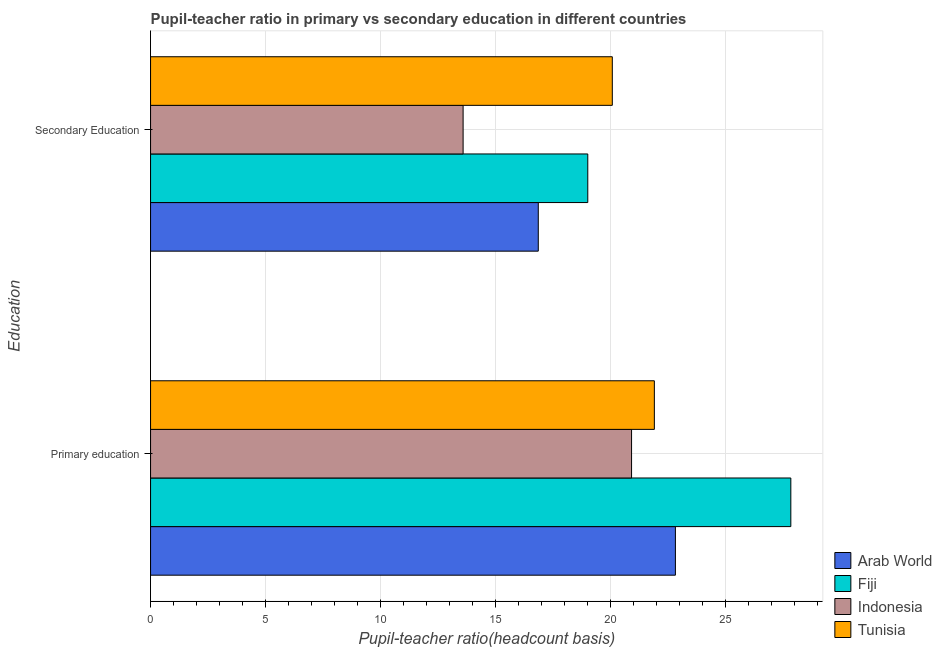How many different coloured bars are there?
Offer a terse response. 4. How many groups of bars are there?
Offer a terse response. 2. What is the pupil teacher ratio on secondary education in Fiji?
Your answer should be compact. 19. Across all countries, what is the maximum pupil-teacher ratio in primary education?
Offer a very short reply. 27.82. Across all countries, what is the minimum pupil-teacher ratio in primary education?
Provide a short and direct response. 20.9. In which country was the pupil teacher ratio on secondary education maximum?
Your answer should be compact. Tunisia. What is the total pupil-teacher ratio in primary education in the graph?
Your answer should be very brief. 93.42. What is the difference between the pupil teacher ratio on secondary education in Arab World and that in Tunisia?
Keep it short and to the point. -3.22. What is the difference between the pupil teacher ratio on secondary education in Arab World and the pupil-teacher ratio in primary education in Fiji?
Your answer should be compact. -10.97. What is the average pupil teacher ratio on secondary education per country?
Provide a short and direct response. 17.37. What is the difference between the pupil-teacher ratio in primary education and pupil teacher ratio on secondary education in Fiji?
Provide a succinct answer. 8.82. What is the ratio of the pupil-teacher ratio in primary education in Fiji to that in Tunisia?
Your answer should be compact. 1.27. What does the 3rd bar from the top in Secondary Education represents?
Your answer should be very brief. Fiji. What does the 2nd bar from the bottom in Secondary Education represents?
Your answer should be compact. Fiji. What is the difference between two consecutive major ticks on the X-axis?
Ensure brevity in your answer.  5. Are the values on the major ticks of X-axis written in scientific E-notation?
Offer a very short reply. No. Where does the legend appear in the graph?
Give a very brief answer. Bottom right. How are the legend labels stacked?
Give a very brief answer. Vertical. What is the title of the graph?
Offer a very short reply. Pupil-teacher ratio in primary vs secondary education in different countries. Does "Kosovo" appear as one of the legend labels in the graph?
Your answer should be very brief. No. What is the label or title of the X-axis?
Offer a very short reply. Pupil-teacher ratio(headcount basis). What is the label or title of the Y-axis?
Provide a short and direct response. Education. What is the Pupil-teacher ratio(headcount basis) of Arab World in Primary education?
Provide a short and direct response. 22.81. What is the Pupil-teacher ratio(headcount basis) of Fiji in Primary education?
Offer a very short reply. 27.82. What is the Pupil-teacher ratio(headcount basis) of Indonesia in Primary education?
Provide a succinct answer. 20.9. What is the Pupil-teacher ratio(headcount basis) in Tunisia in Primary education?
Ensure brevity in your answer.  21.89. What is the Pupil-teacher ratio(headcount basis) in Arab World in Secondary Education?
Keep it short and to the point. 16.85. What is the Pupil-teacher ratio(headcount basis) in Fiji in Secondary Education?
Keep it short and to the point. 19. What is the Pupil-teacher ratio(headcount basis) of Indonesia in Secondary Education?
Your response must be concise. 13.58. What is the Pupil-teacher ratio(headcount basis) in Tunisia in Secondary Education?
Your answer should be very brief. 20.07. Across all Education, what is the maximum Pupil-teacher ratio(headcount basis) of Arab World?
Ensure brevity in your answer.  22.81. Across all Education, what is the maximum Pupil-teacher ratio(headcount basis) in Fiji?
Your answer should be very brief. 27.82. Across all Education, what is the maximum Pupil-teacher ratio(headcount basis) in Indonesia?
Provide a succinct answer. 20.9. Across all Education, what is the maximum Pupil-teacher ratio(headcount basis) of Tunisia?
Give a very brief answer. 21.89. Across all Education, what is the minimum Pupil-teacher ratio(headcount basis) of Arab World?
Keep it short and to the point. 16.85. Across all Education, what is the minimum Pupil-teacher ratio(headcount basis) in Fiji?
Ensure brevity in your answer.  19. Across all Education, what is the minimum Pupil-teacher ratio(headcount basis) of Indonesia?
Keep it short and to the point. 13.58. Across all Education, what is the minimum Pupil-teacher ratio(headcount basis) of Tunisia?
Ensure brevity in your answer.  20.07. What is the total Pupil-teacher ratio(headcount basis) of Arab World in the graph?
Ensure brevity in your answer.  39.66. What is the total Pupil-teacher ratio(headcount basis) in Fiji in the graph?
Keep it short and to the point. 46.82. What is the total Pupil-teacher ratio(headcount basis) of Indonesia in the graph?
Your answer should be compact. 34.48. What is the total Pupil-teacher ratio(headcount basis) in Tunisia in the graph?
Offer a very short reply. 41.96. What is the difference between the Pupil-teacher ratio(headcount basis) in Arab World in Primary education and that in Secondary Education?
Provide a short and direct response. 5.96. What is the difference between the Pupil-teacher ratio(headcount basis) of Fiji in Primary education and that in Secondary Education?
Provide a succinct answer. 8.82. What is the difference between the Pupil-teacher ratio(headcount basis) of Indonesia in Primary education and that in Secondary Education?
Offer a very short reply. 7.32. What is the difference between the Pupil-teacher ratio(headcount basis) of Tunisia in Primary education and that in Secondary Education?
Ensure brevity in your answer.  1.83. What is the difference between the Pupil-teacher ratio(headcount basis) of Arab World in Primary education and the Pupil-teacher ratio(headcount basis) of Fiji in Secondary Education?
Your answer should be very brief. 3.81. What is the difference between the Pupil-teacher ratio(headcount basis) of Arab World in Primary education and the Pupil-teacher ratio(headcount basis) of Indonesia in Secondary Education?
Provide a succinct answer. 9.23. What is the difference between the Pupil-teacher ratio(headcount basis) of Arab World in Primary education and the Pupil-teacher ratio(headcount basis) of Tunisia in Secondary Education?
Offer a very short reply. 2.74. What is the difference between the Pupil-teacher ratio(headcount basis) in Fiji in Primary education and the Pupil-teacher ratio(headcount basis) in Indonesia in Secondary Education?
Your answer should be compact. 14.24. What is the difference between the Pupil-teacher ratio(headcount basis) in Fiji in Primary education and the Pupil-teacher ratio(headcount basis) in Tunisia in Secondary Education?
Your response must be concise. 7.76. What is the difference between the Pupil-teacher ratio(headcount basis) of Indonesia in Primary education and the Pupil-teacher ratio(headcount basis) of Tunisia in Secondary Education?
Offer a very short reply. 0.84. What is the average Pupil-teacher ratio(headcount basis) of Arab World per Education?
Provide a short and direct response. 19.83. What is the average Pupil-teacher ratio(headcount basis) of Fiji per Education?
Provide a succinct answer. 23.41. What is the average Pupil-teacher ratio(headcount basis) of Indonesia per Education?
Make the answer very short. 17.24. What is the average Pupil-teacher ratio(headcount basis) in Tunisia per Education?
Your answer should be very brief. 20.98. What is the difference between the Pupil-teacher ratio(headcount basis) of Arab World and Pupil-teacher ratio(headcount basis) of Fiji in Primary education?
Your response must be concise. -5.02. What is the difference between the Pupil-teacher ratio(headcount basis) of Arab World and Pupil-teacher ratio(headcount basis) of Indonesia in Primary education?
Offer a very short reply. 1.91. What is the difference between the Pupil-teacher ratio(headcount basis) in Arab World and Pupil-teacher ratio(headcount basis) in Tunisia in Primary education?
Make the answer very short. 0.92. What is the difference between the Pupil-teacher ratio(headcount basis) in Fiji and Pupil-teacher ratio(headcount basis) in Indonesia in Primary education?
Keep it short and to the point. 6.92. What is the difference between the Pupil-teacher ratio(headcount basis) in Fiji and Pupil-teacher ratio(headcount basis) in Tunisia in Primary education?
Your answer should be very brief. 5.93. What is the difference between the Pupil-teacher ratio(headcount basis) of Indonesia and Pupil-teacher ratio(headcount basis) of Tunisia in Primary education?
Offer a terse response. -0.99. What is the difference between the Pupil-teacher ratio(headcount basis) in Arab World and Pupil-teacher ratio(headcount basis) in Fiji in Secondary Education?
Make the answer very short. -2.15. What is the difference between the Pupil-teacher ratio(headcount basis) in Arab World and Pupil-teacher ratio(headcount basis) in Indonesia in Secondary Education?
Offer a very short reply. 3.27. What is the difference between the Pupil-teacher ratio(headcount basis) in Arab World and Pupil-teacher ratio(headcount basis) in Tunisia in Secondary Education?
Give a very brief answer. -3.22. What is the difference between the Pupil-teacher ratio(headcount basis) of Fiji and Pupil-teacher ratio(headcount basis) of Indonesia in Secondary Education?
Provide a short and direct response. 5.42. What is the difference between the Pupil-teacher ratio(headcount basis) in Fiji and Pupil-teacher ratio(headcount basis) in Tunisia in Secondary Education?
Provide a succinct answer. -1.07. What is the difference between the Pupil-teacher ratio(headcount basis) in Indonesia and Pupil-teacher ratio(headcount basis) in Tunisia in Secondary Education?
Offer a terse response. -6.48. What is the ratio of the Pupil-teacher ratio(headcount basis) in Arab World in Primary education to that in Secondary Education?
Offer a terse response. 1.35. What is the ratio of the Pupil-teacher ratio(headcount basis) of Fiji in Primary education to that in Secondary Education?
Give a very brief answer. 1.46. What is the ratio of the Pupil-teacher ratio(headcount basis) in Indonesia in Primary education to that in Secondary Education?
Provide a succinct answer. 1.54. What is the ratio of the Pupil-teacher ratio(headcount basis) in Tunisia in Primary education to that in Secondary Education?
Make the answer very short. 1.09. What is the difference between the highest and the second highest Pupil-teacher ratio(headcount basis) of Arab World?
Ensure brevity in your answer.  5.96. What is the difference between the highest and the second highest Pupil-teacher ratio(headcount basis) of Fiji?
Ensure brevity in your answer.  8.82. What is the difference between the highest and the second highest Pupil-teacher ratio(headcount basis) of Indonesia?
Provide a short and direct response. 7.32. What is the difference between the highest and the second highest Pupil-teacher ratio(headcount basis) in Tunisia?
Ensure brevity in your answer.  1.83. What is the difference between the highest and the lowest Pupil-teacher ratio(headcount basis) in Arab World?
Your answer should be compact. 5.96. What is the difference between the highest and the lowest Pupil-teacher ratio(headcount basis) in Fiji?
Offer a very short reply. 8.82. What is the difference between the highest and the lowest Pupil-teacher ratio(headcount basis) in Indonesia?
Provide a short and direct response. 7.32. What is the difference between the highest and the lowest Pupil-teacher ratio(headcount basis) of Tunisia?
Offer a terse response. 1.83. 